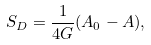Convert formula to latex. <formula><loc_0><loc_0><loc_500><loc_500>S _ { D } = \frac { 1 } { 4 G } ( A _ { 0 } - A ) ,</formula> 